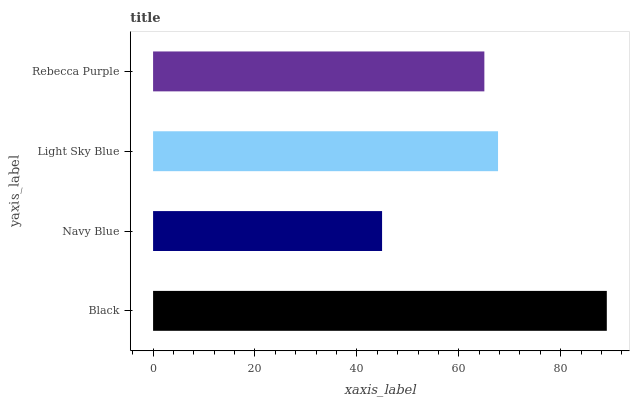Is Navy Blue the minimum?
Answer yes or no. Yes. Is Black the maximum?
Answer yes or no. Yes. Is Light Sky Blue the minimum?
Answer yes or no. No. Is Light Sky Blue the maximum?
Answer yes or no. No. Is Light Sky Blue greater than Navy Blue?
Answer yes or no. Yes. Is Navy Blue less than Light Sky Blue?
Answer yes or no. Yes. Is Navy Blue greater than Light Sky Blue?
Answer yes or no. No. Is Light Sky Blue less than Navy Blue?
Answer yes or no. No. Is Light Sky Blue the high median?
Answer yes or no. Yes. Is Rebecca Purple the low median?
Answer yes or no. Yes. Is Black the high median?
Answer yes or no. No. Is Light Sky Blue the low median?
Answer yes or no. No. 